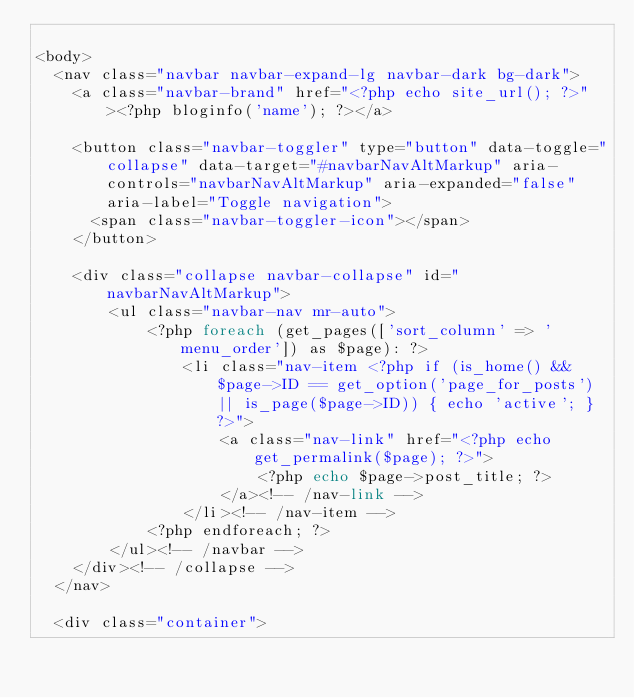<code> <loc_0><loc_0><loc_500><loc_500><_PHP_>
<body>
  <nav class="navbar navbar-expand-lg navbar-dark bg-dark">
    <a class="navbar-brand" href="<?php echo site_url(); ?>"><?php bloginfo('name'); ?></a>
  
    <button class="navbar-toggler" type="button" data-toggle="collapse" data-target="#navbarNavAltMarkup" aria-controls="navbarNavAltMarkup" aria-expanded="false" aria-label="Toggle navigation">
      <span class="navbar-toggler-icon"></span>
    </button>
    
    <div class="collapse navbar-collapse" id="navbarNavAltMarkup">
        <ul class="navbar-nav mr-auto">
            <?php foreach (get_pages(['sort_column' => 'menu_order']) as $page): ?>
                <li class="nav-item <?php if (is_home() && $page->ID == get_option('page_for_posts') || is_page($page->ID)) { echo 'active'; } ?>">
                    <a class="nav-link" href="<?php echo get_permalink($page); ?>">
                        <?php echo $page->post_title; ?>
                    </a><!-- /nav-link -->
                </li><!-- /nav-item -->
            <?php endforeach; ?>
        </ul><!-- /navbar -->
    </div><!-- /collapse -->
  </nav>

  <div class="container"></code> 